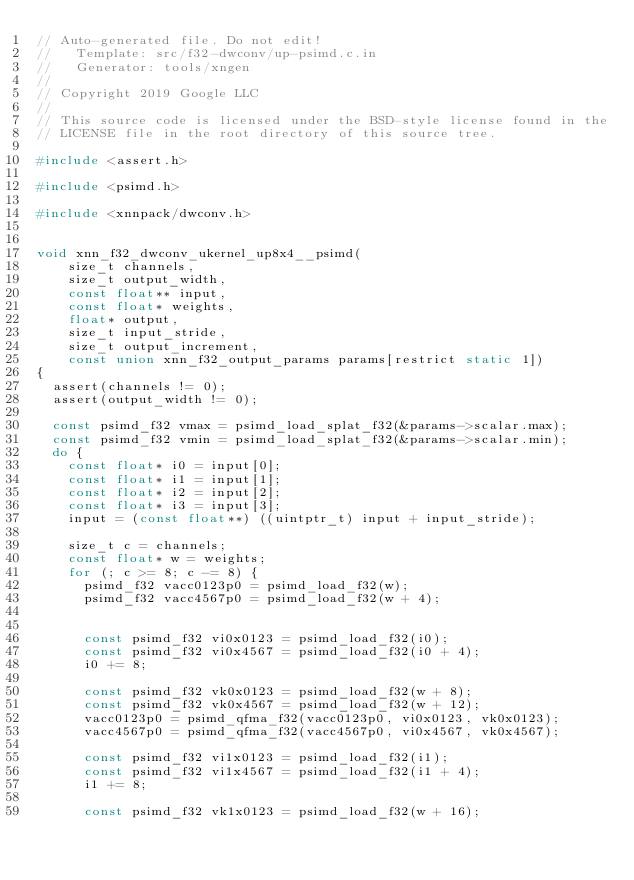<code> <loc_0><loc_0><loc_500><loc_500><_C_>// Auto-generated file. Do not edit!
//   Template: src/f32-dwconv/up-psimd.c.in
//   Generator: tools/xngen
//
// Copyright 2019 Google LLC
//
// This source code is licensed under the BSD-style license found in the
// LICENSE file in the root directory of this source tree.

#include <assert.h>

#include <psimd.h>

#include <xnnpack/dwconv.h>


void xnn_f32_dwconv_ukernel_up8x4__psimd(
    size_t channels,
    size_t output_width,
    const float** input,
    const float* weights,
    float* output,
    size_t input_stride,
    size_t output_increment,
    const union xnn_f32_output_params params[restrict static 1])
{
  assert(channels != 0);
  assert(output_width != 0);

  const psimd_f32 vmax = psimd_load_splat_f32(&params->scalar.max);
  const psimd_f32 vmin = psimd_load_splat_f32(&params->scalar.min);
  do {
    const float* i0 = input[0];
    const float* i1 = input[1];
    const float* i2 = input[2];
    const float* i3 = input[3];
    input = (const float**) ((uintptr_t) input + input_stride);

    size_t c = channels;
    const float* w = weights;
    for (; c >= 8; c -= 8) {
      psimd_f32 vacc0123p0 = psimd_load_f32(w);
      psimd_f32 vacc4567p0 = psimd_load_f32(w + 4);


      const psimd_f32 vi0x0123 = psimd_load_f32(i0);
      const psimd_f32 vi0x4567 = psimd_load_f32(i0 + 4);
      i0 += 8;

      const psimd_f32 vk0x0123 = psimd_load_f32(w + 8);
      const psimd_f32 vk0x4567 = psimd_load_f32(w + 12);
      vacc0123p0 = psimd_qfma_f32(vacc0123p0, vi0x0123, vk0x0123);
      vacc4567p0 = psimd_qfma_f32(vacc4567p0, vi0x4567, vk0x4567);

      const psimd_f32 vi1x0123 = psimd_load_f32(i1);
      const psimd_f32 vi1x4567 = psimd_load_f32(i1 + 4);
      i1 += 8;

      const psimd_f32 vk1x0123 = psimd_load_f32(w + 16);</code> 